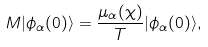<formula> <loc_0><loc_0><loc_500><loc_500>M | \phi _ { \alpha } ( 0 ) \rangle = \frac { \mu _ { \alpha } ( \chi ) } { T } | \phi _ { \alpha } ( 0 ) \rangle ,</formula> 